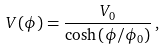Convert formula to latex. <formula><loc_0><loc_0><loc_500><loc_500>V ( \phi ) = \frac { V _ { 0 } } { \cosh \left ( \phi / \phi _ { 0 } \right ) } \, ,</formula> 